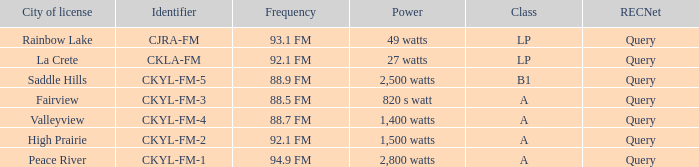What is the frequency that has a fairview city of license 88.5 FM. 